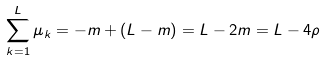<formula> <loc_0><loc_0><loc_500><loc_500>\sum _ { k = 1 } ^ { L } \mu _ { k } = - m + ( L - m ) = L - 2 m = L - 4 \rho</formula> 